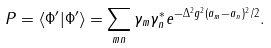<formula> <loc_0><loc_0><loc_500><loc_500>P = \langle \Phi ^ { \prime } | \Phi ^ { \prime } \rangle = \sum _ { m n } \gamma _ { m } \gamma ^ { * } _ { n } e ^ { - { \Delta ^ { 2 } g ^ { 2 } ( a _ { m } - a _ { n } ) ^ { 2 } } / 2 } .</formula> 